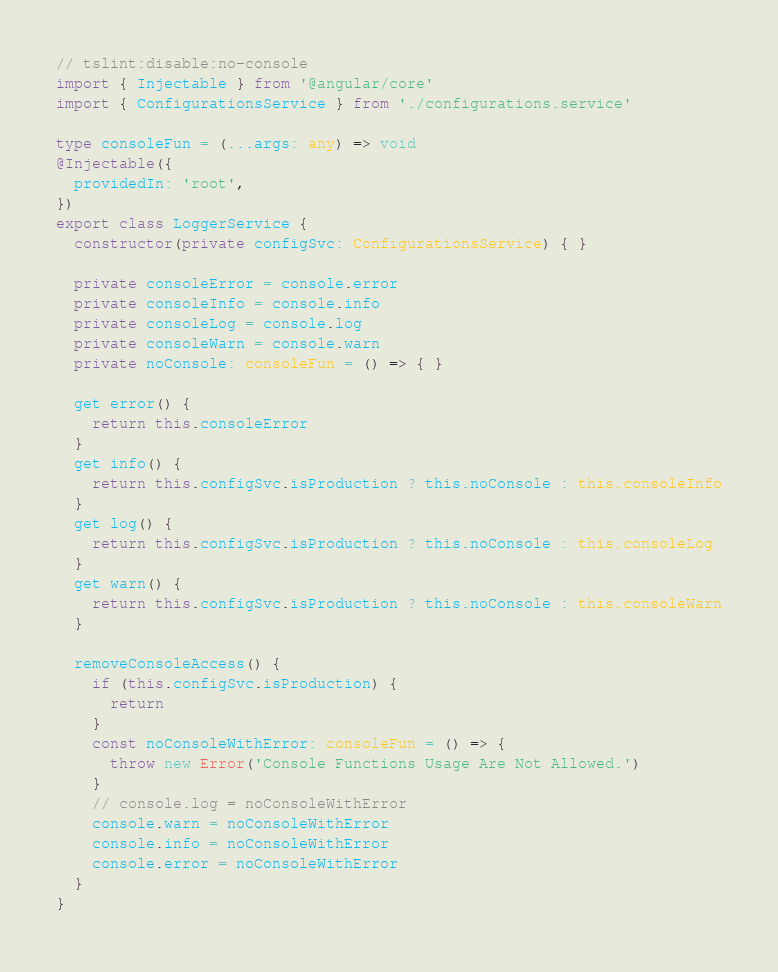<code> <loc_0><loc_0><loc_500><loc_500><_TypeScript_>// tslint:disable:no-console
import { Injectable } from '@angular/core'
import { ConfigurationsService } from './configurations.service'

type consoleFun = (...args: any) => void
@Injectable({
  providedIn: 'root',
})
export class LoggerService {
  constructor(private configSvc: ConfigurationsService) { }

  private consoleError = console.error
  private consoleInfo = console.info
  private consoleLog = console.log
  private consoleWarn = console.warn
  private noConsole: consoleFun = () => { }

  get error() {
    return this.consoleError
  }
  get info() {
    return this.configSvc.isProduction ? this.noConsole : this.consoleInfo
  }
  get log() {
    return this.configSvc.isProduction ? this.noConsole : this.consoleLog
  }
  get warn() {
    return this.configSvc.isProduction ? this.noConsole : this.consoleWarn
  }

  removeConsoleAccess() {
    if (this.configSvc.isProduction) {
      return
    }
    const noConsoleWithError: consoleFun = () => {
      throw new Error('Console Functions Usage Are Not Allowed.')
    }
    // console.log = noConsoleWithError
    console.warn = noConsoleWithError
    console.info = noConsoleWithError
    console.error = noConsoleWithError
  }
}
</code> 